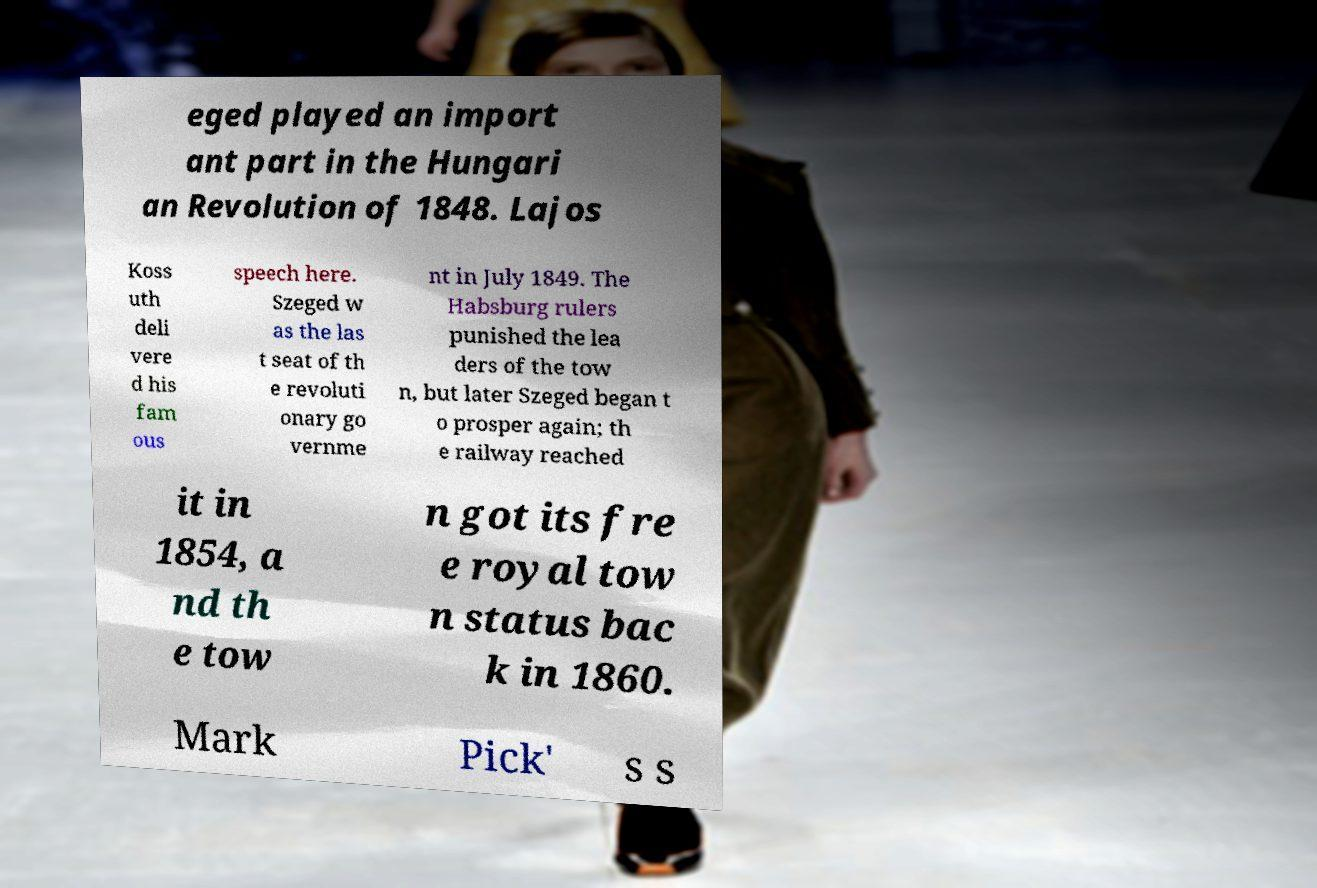I need the written content from this picture converted into text. Can you do that? eged played an import ant part in the Hungari an Revolution of 1848. Lajos Koss uth deli vere d his fam ous speech here. Szeged w as the las t seat of th e revoluti onary go vernme nt in July 1849. The Habsburg rulers punished the lea ders of the tow n, but later Szeged began t o prosper again; th e railway reached it in 1854, a nd th e tow n got its fre e royal tow n status bac k in 1860. Mark Pick' s s 